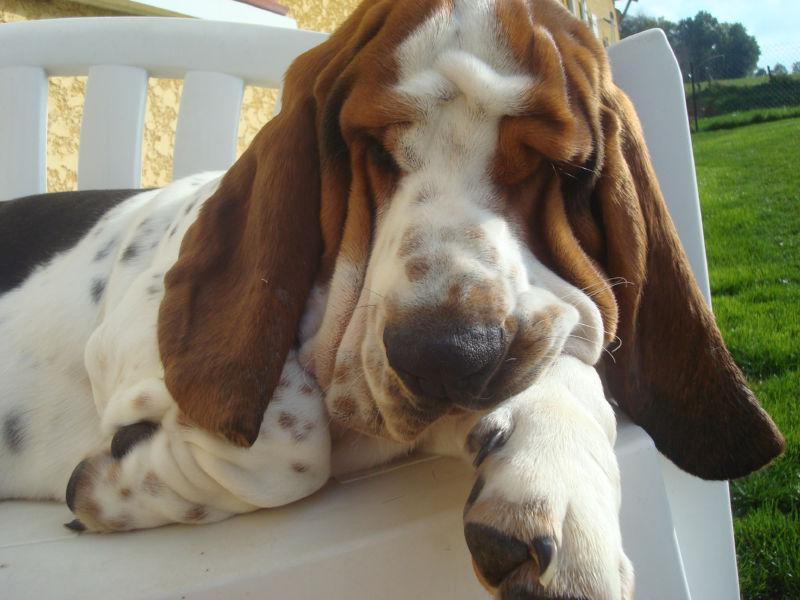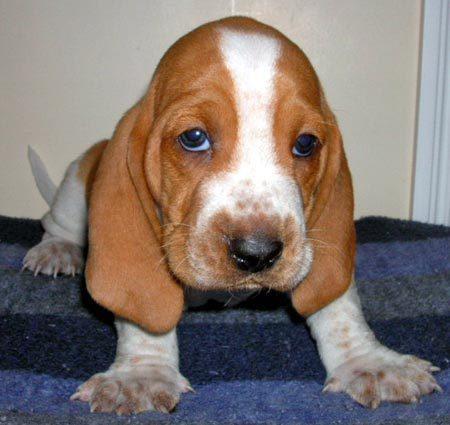The first image is the image on the left, the second image is the image on the right. For the images displayed, is the sentence "One of the dog has its chin on a surface." factually correct? Answer yes or no. Yes. 